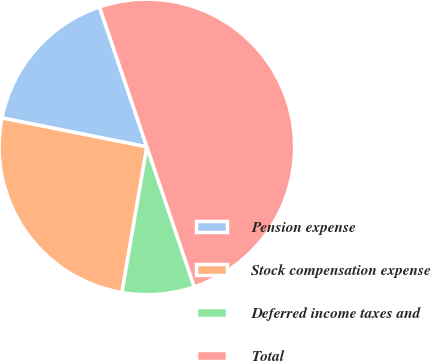Convert chart. <chart><loc_0><loc_0><loc_500><loc_500><pie_chart><fcel>Pension expense<fcel>Stock compensation expense<fcel>Deferred income taxes and<fcel>Total<nl><fcel>16.67%<fcel>25.44%<fcel>7.89%<fcel>50.0%<nl></chart> 